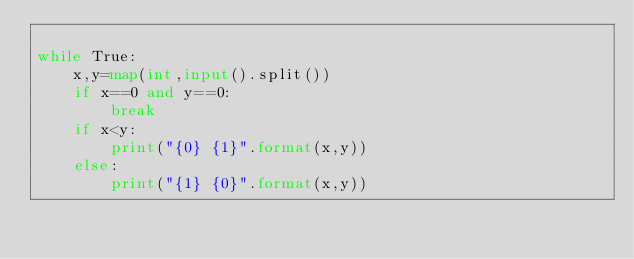<code> <loc_0><loc_0><loc_500><loc_500><_Python_>
while True:
    x,y=map(int,input().split())
    if x==0 and y==0:
        break
    if x<y:
        print("{0} {1}".format(x,y))
    else:
        print("{1} {0}".format(x,y))
    
    


</code> 